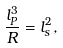Convert formula to latex. <formula><loc_0><loc_0><loc_500><loc_500>\frac { l _ { P } ^ { 3 } } { R } = l _ { s } ^ { 2 } ,</formula> 